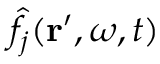<formula> <loc_0><loc_0><loc_500><loc_500>\hat { f } _ { j } ( r ^ { \prime } , \omega , t )</formula> 